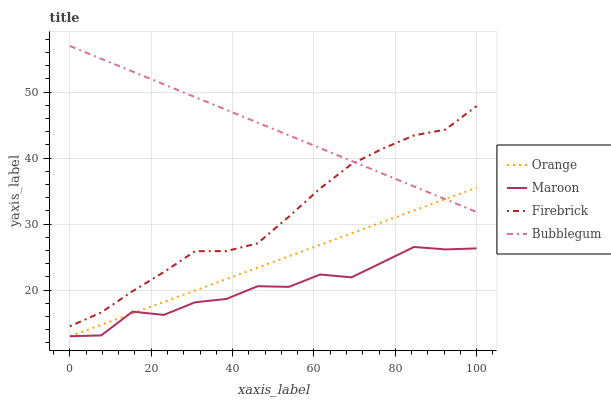Does Maroon have the minimum area under the curve?
Answer yes or no. Yes. Does Bubblegum have the maximum area under the curve?
Answer yes or no. Yes. Does Firebrick have the minimum area under the curve?
Answer yes or no. No. Does Firebrick have the maximum area under the curve?
Answer yes or no. No. Is Orange the smoothest?
Answer yes or no. Yes. Is Maroon the roughest?
Answer yes or no. Yes. Is Firebrick the smoothest?
Answer yes or no. No. Is Firebrick the roughest?
Answer yes or no. No. Does Firebrick have the lowest value?
Answer yes or no. No. Does Firebrick have the highest value?
Answer yes or no. No. Is Maroon less than Bubblegum?
Answer yes or no. Yes. Is Bubblegum greater than Maroon?
Answer yes or no. Yes. Does Maroon intersect Bubblegum?
Answer yes or no. No. 